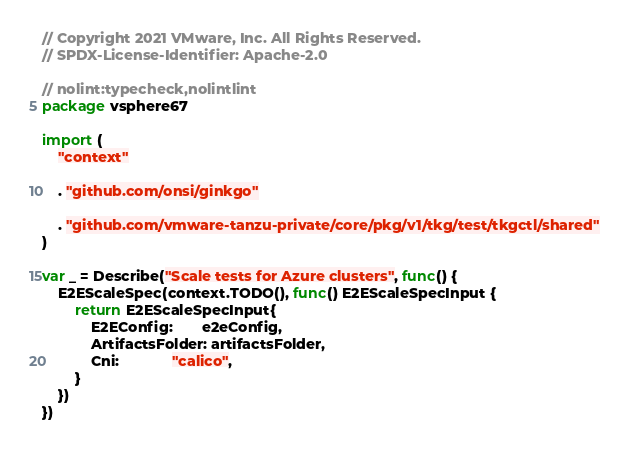<code> <loc_0><loc_0><loc_500><loc_500><_Go_>// Copyright 2021 VMware, Inc. All Rights Reserved.
// SPDX-License-Identifier: Apache-2.0

// nolint:typecheck,nolintlint
package vsphere67

import (
	"context"

	. "github.com/onsi/ginkgo"

	. "github.com/vmware-tanzu-private/core/pkg/v1/tkg/test/tkgctl/shared"
)

var _ = Describe("Scale tests for Azure clusters", func() {
	E2EScaleSpec(context.TODO(), func() E2EScaleSpecInput {
		return E2EScaleSpecInput{
			E2EConfig:       e2eConfig,
			ArtifactsFolder: artifactsFolder,
			Cni:             "calico",
		}
	})
})
</code> 